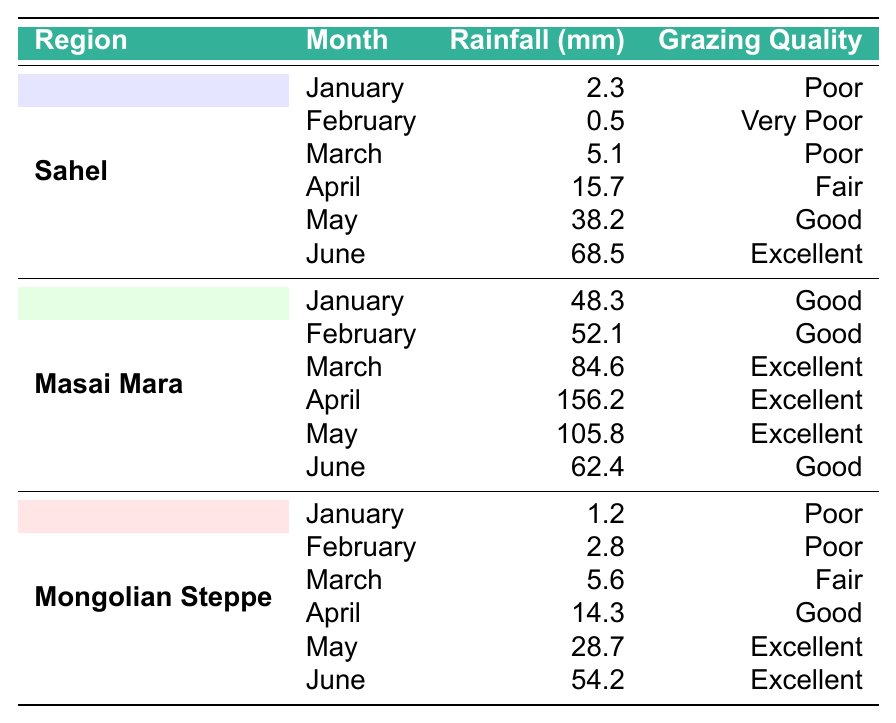What was the rainfall in Masai Mara in April? The table shows that in April, the rainfall for the Masai Mara region was 156.2 mm.
Answer: 156.2 mm Which month had the highest rainfall in the Mongolian Steppe? By examining the table, we can see that the highest rainfall in the Mongolian Steppe was in June, with 54.2 mm.
Answer: June What is the total rainfall recorded in the Sahel during the months of March, April, and May? For the Sahel region, the rainfall for March is 5.1 mm, April is 15.7 mm, and May is 38.2 mm. Adding these together gives us 5.1 + 15.7 + 38.2 = 59.0 mm.
Answer: 59.0 mm Is the grazing quality in the Mongolian Steppe ever rated as 'Excellent'? The table indicates that both May and June for the Mongolian Steppe had an 'Excellent' grazing quality rating.
Answer: Yes What was the average rainfall for the Masai Mara from January to June? To calculate the average, we take the sum of the rainfall across all six months: 48.3 + 52.1 + 84.6 + 156.2 + 105.8 + 62.4 = 509.4 mm. Dividing by 6 gives an average of 509.4 / 6 ≈ 84.9 mm.
Answer: 84.9 mm Which region consistently received poor grazing quality during the earlier months of the year (January to March)? Reviewing the table, the Sahel region received 'Poor' or 'Very Poor' quality from January to March (Poor in January, Very Poor in February, and Poor in March).
Answer: Sahel What was the rainfall in May compared to June for the Masai Mara? In May, the rainfall was 105.8 mm, and in June, it was 62.4 mm. The difference in rainfall between May and June is 105.8 - 62.4 = 43.4 mm. Therefore, May had greater rainfall than June.
Answer: May had 43.4 mm more Has any month exceeded 70 mm of rainfall in the Sahel? By examining the data for the Sahel, June with 68.5 mm is the highest, which does not exceed 70 mm. Therefore, no months surpassed 70 mm.
Answer: No In which months did the grazing quality in the Sahel improve from 'Poor' to 'Good'? According to the table, the grazing quality in Sahel improved to 'Good' starting in May, moving from 'Poor' (January and March) and 'Fair' (April) before reaching 'Good'.
Answer: From April to May How many total months experienced 'Excellent' grazing quality across all regions? Analyzing the data, 'Excellent' grazing quality occurred in June for Sahel, March, April, and May for Masai Mara, and May and June for Mongolian Steppe, totaling 5 months.
Answer: 5 months 